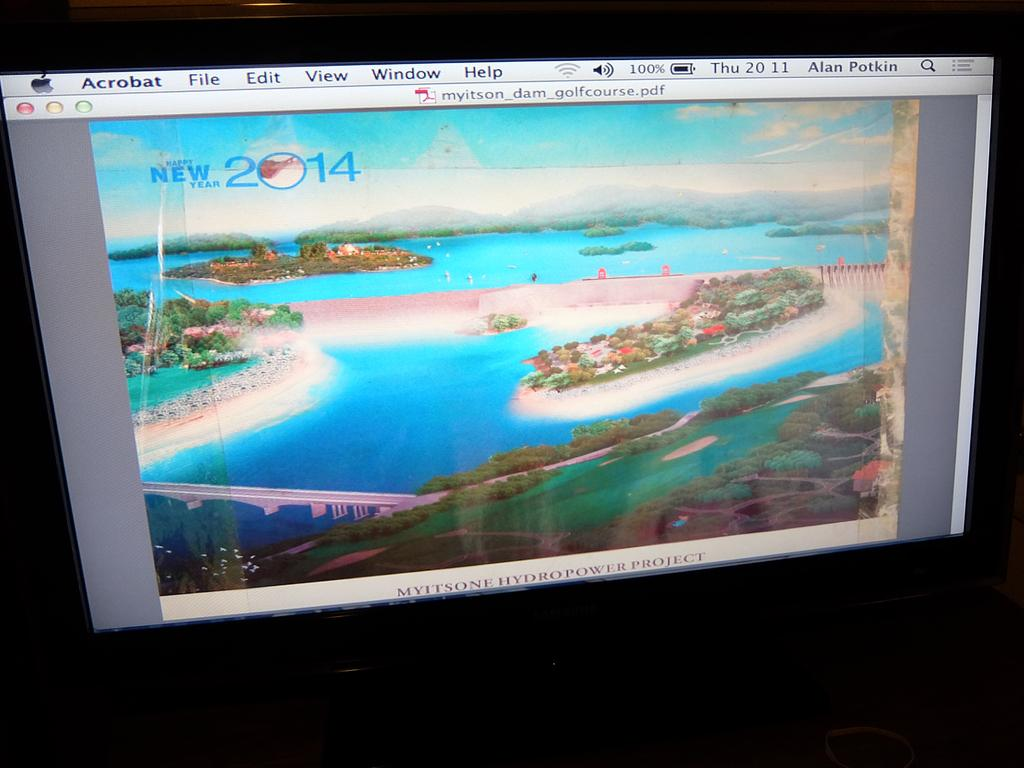<image>
Provide a brief description of the given image. an Acrobat program that is on the television 